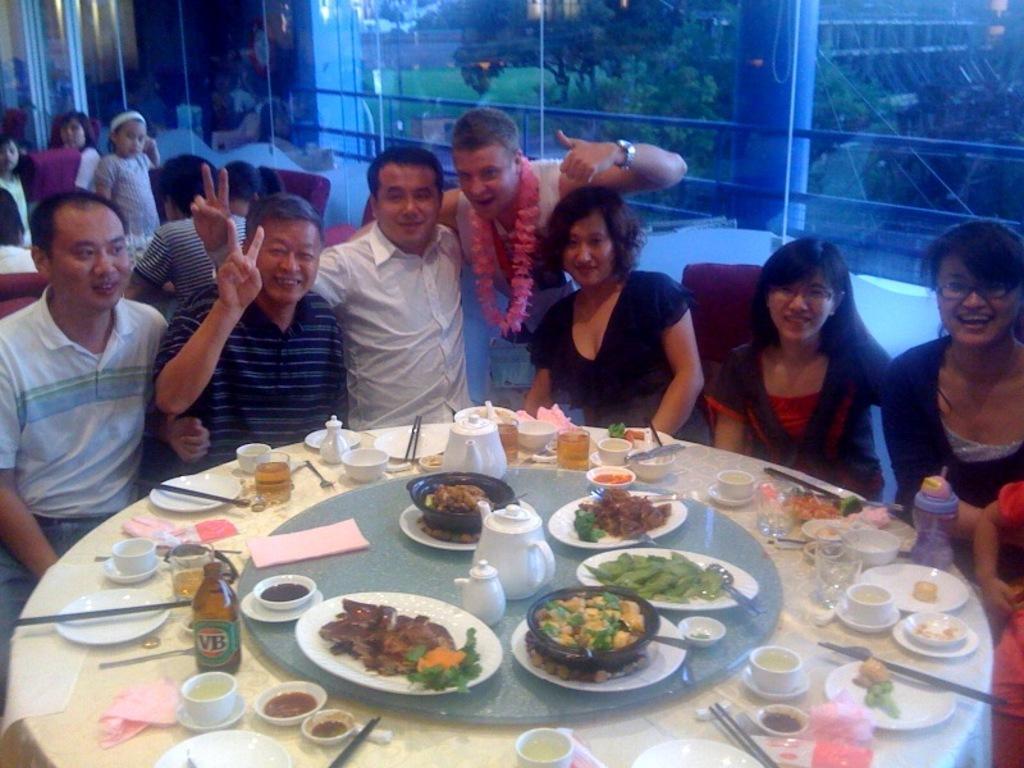How would you summarize this image in a sentence or two? In the picture we can see some men and women are sitting around the table, and on the table, we can see the food items, jars, spoons, bottles, cups and bowls and in the background, we can see some people are sitting near the table and beside them we can see the glass wall. 